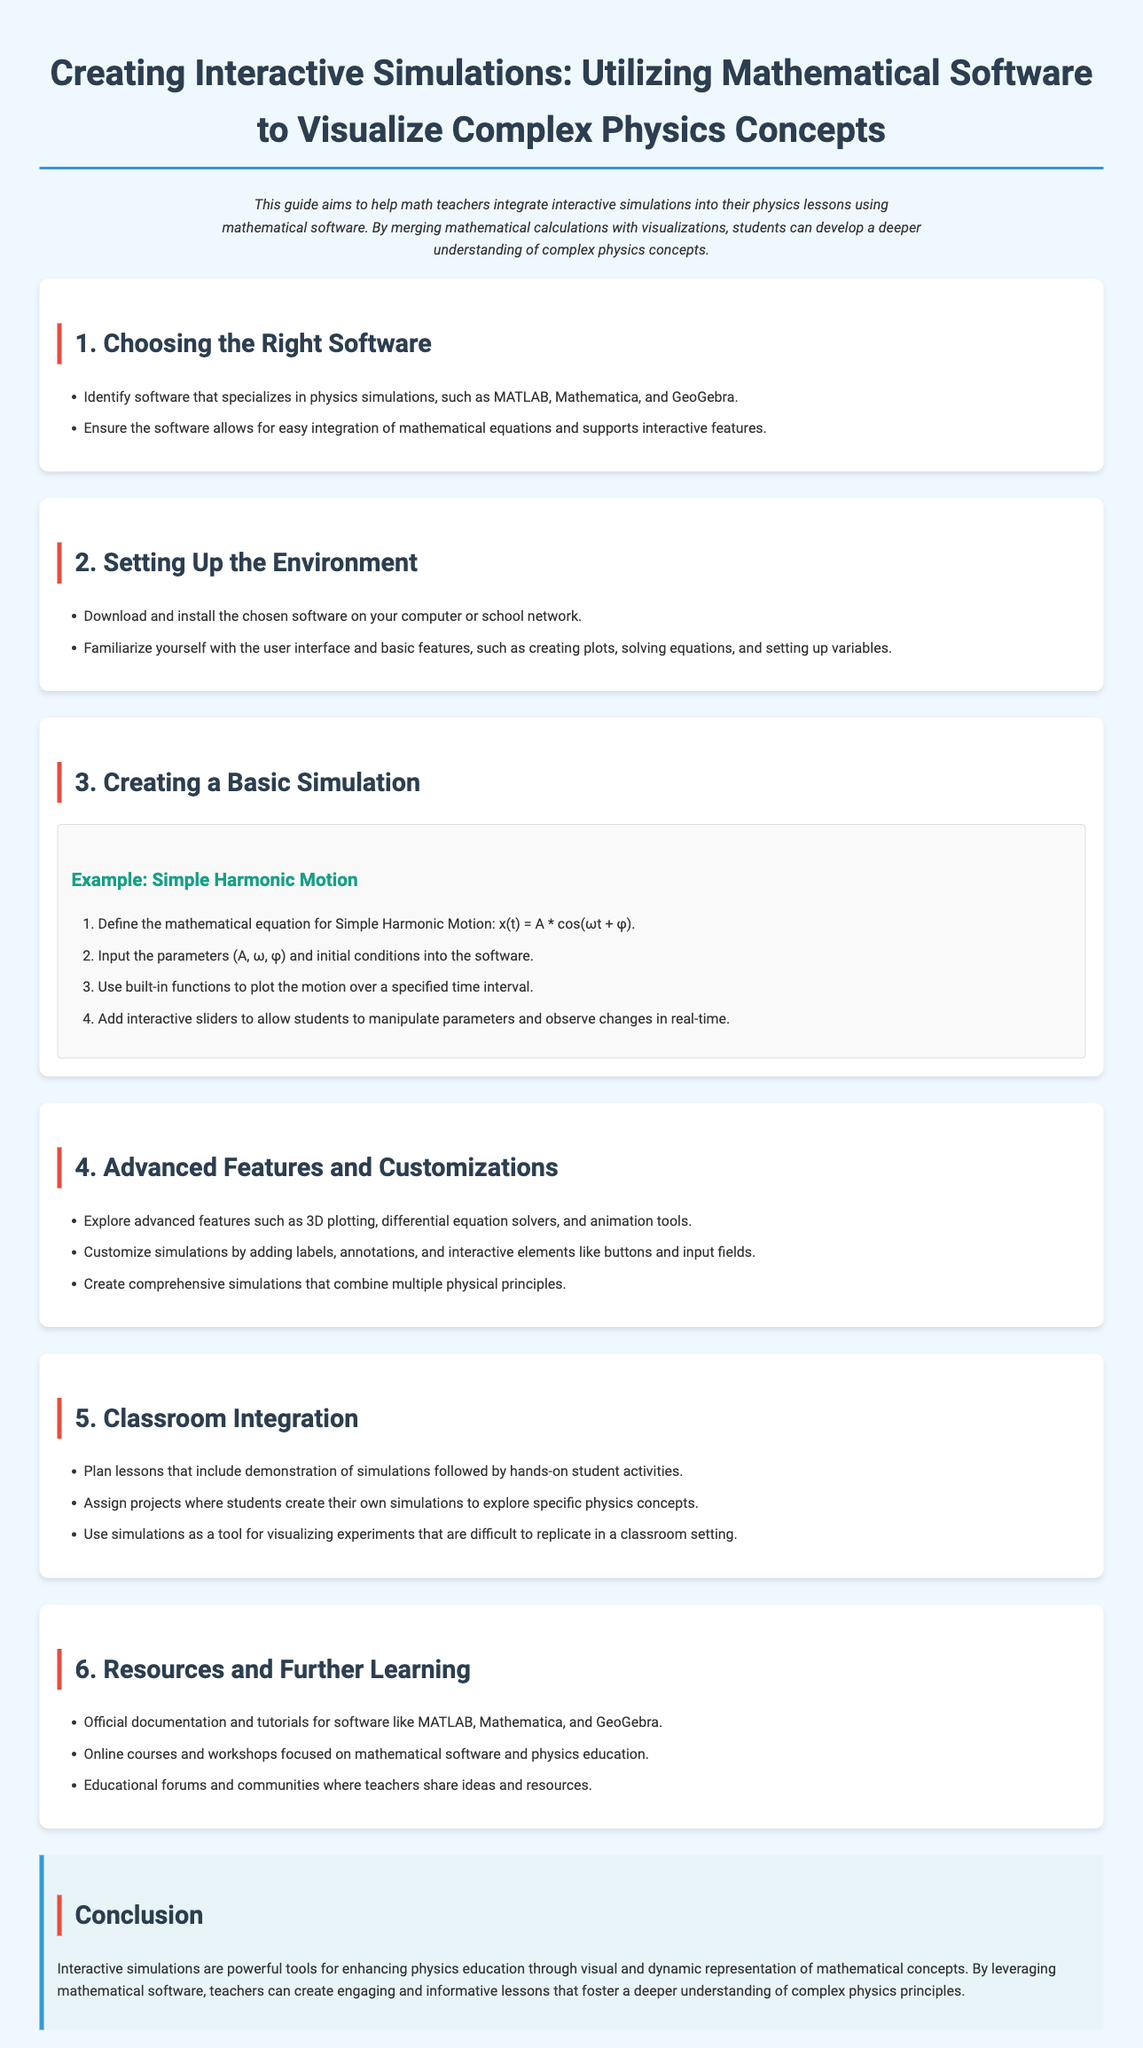What is the title of the user guide? The title is stated prominently at the beginning of the document as the main heading.
Answer: Creating Interactive Simulations: Utilizing Mathematical Software to Visualize Complex Physics Concepts Which software is suggested for creating simulations? The document lists specific software that specializes in physics simulations in the first section.
Answer: MATLAB, Mathematica, GeoGebra What is the basic equation for Simple Harmonic Motion? The document provides the equation used in the example section for Simple Harmonic Motion.
Answer: x(t) = A * cos(ωt + φ) How many sections are there in the document? The number of sections can be counted in the structured format of the user guide where each section is distinctly labeled.
Answer: Six What is one advanced feature mentioned for simulations? The document discusses several advanced features in the relevant section, highlighting tools that enhance simulations.
Answer: 3D plotting 